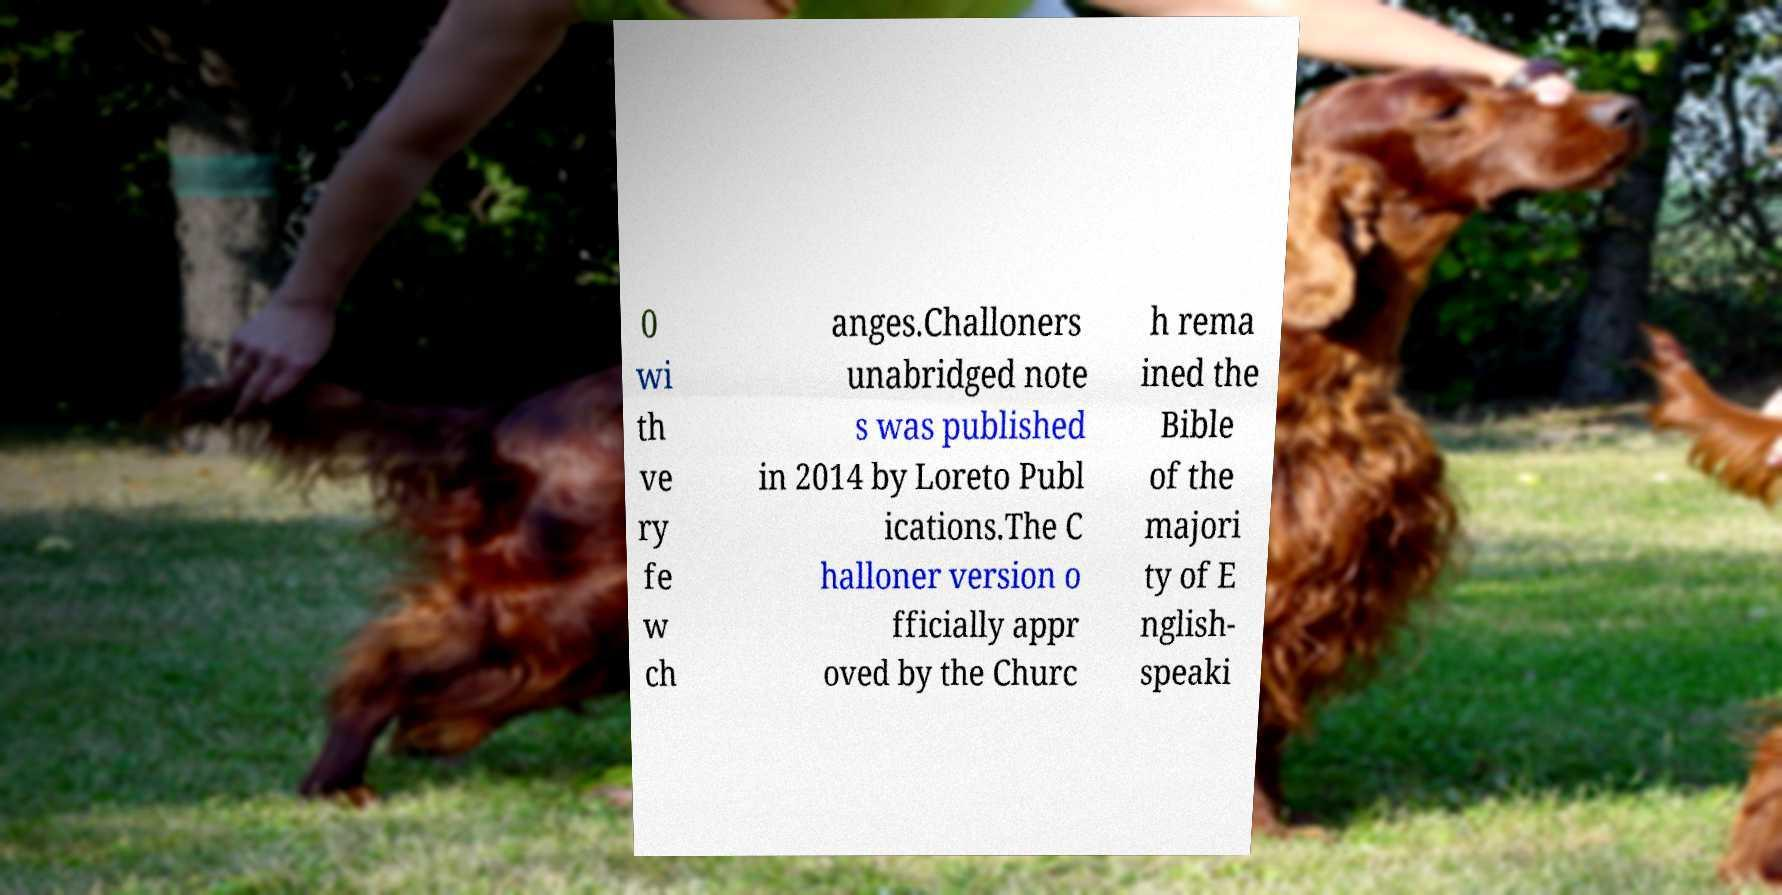Could you assist in decoding the text presented in this image and type it out clearly? 0 wi th ve ry fe w ch anges.Challoners unabridged note s was published in 2014 by Loreto Publ ications.The C halloner version o fficially appr oved by the Churc h rema ined the Bible of the majori ty of E nglish- speaki 